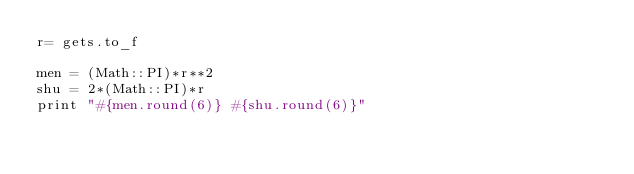Convert code to text. <code><loc_0><loc_0><loc_500><loc_500><_Ruby_>r= gets.to_f

men = (Math::PI)*r**2
shu = 2*(Math::PI)*r
print "#{men.round(6)} #{shu.round(6)}" </code> 